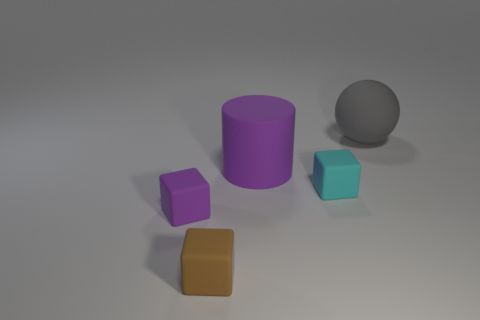Does the large rubber thing on the left side of the big ball have the same color as the cube to the left of the tiny brown matte cube?
Give a very brief answer. Yes. Is there any other thing that is the same color as the big cylinder?
Provide a succinct answer. Yes. Is there a brown rubber block that is to the right of the purple matte thing in front of the tiny cyan rubber thing?
Offer a very short reply. Yes. Is there a purple matte thing that has the same shape as the small brown object?
Provide a succinct answer. Yes. There is a purple thing to the right of the purple thing on the left side of the cylinder; what is its material?
Your response must be concise. Rubber. How big is the cyan cube?
Your answer should be very brief. Small. There is a cyan block that is the same material as the big gray object; what size is it?
Make the answer very short. Small. Is the size of the purple object that is right of the brown rubber object the same as the large gray ball?
Provide a succinct answer. Yes. What is the shape of the brown thing that is left of the cube that is on the right side of the big matte object that is in front of the large rubber sphere?
Keep it short and to the point. Cube. How many things are either tiny purple matte cubes or things in front of the sphere?
Offer a very short reply. 4. 